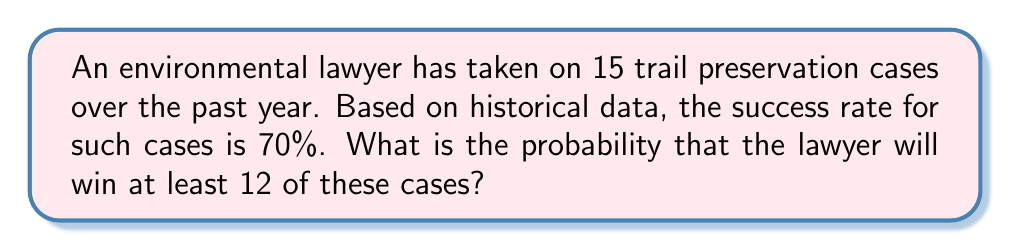Give your solution to this math problem. To solve this problem, we'll use the binomial probability distribution:

1. Define variables:
   $n = 15$ (number of cases)
   $p = 0.70$ (probability of success for each case)
   $X$ = number of successful cases
   We want $P(X \geq 12)$

2. The probability of at least 12 successes is equal to the sum of probabilities for 12, 13, 14, and 15 successes:
   $P(X \geq 12) = P(X = 12) + P(X = 13) + P(X = 14) + P(X = 15)$

3. Use the binomial probability formula for each case:
   $P(X = k) = \binom{n}{k} p^k (1-p)^{n-k}$

4. Calculate each probability:
   $P(X = 12) = \binom{15}{12} (0.70)^{12} (0.30)^3 = 0.2252$
   $P(X = 13) = \binom{15}{13} (0.70)^{13} (0.30)^2 = 0.1366$
   $P(X = 14) = \binom{15}{14} (0.70)^{14} (0.30)^1 = 0.0488$
   $P(X = 15) = \binom{15}{15} (0.70)^{15} (0.30)^0 = 0.0075$

5. Sum the probabilities:
   $P(X \geq 12) = 0.2252 + 0.1366 + 0.0488 + 0.0075 = 0.4181$

Therefore, the probability of winning at least 12 out of 15 cases is approximately 0.4181 or 41.81%.
Answer: 0.4181 